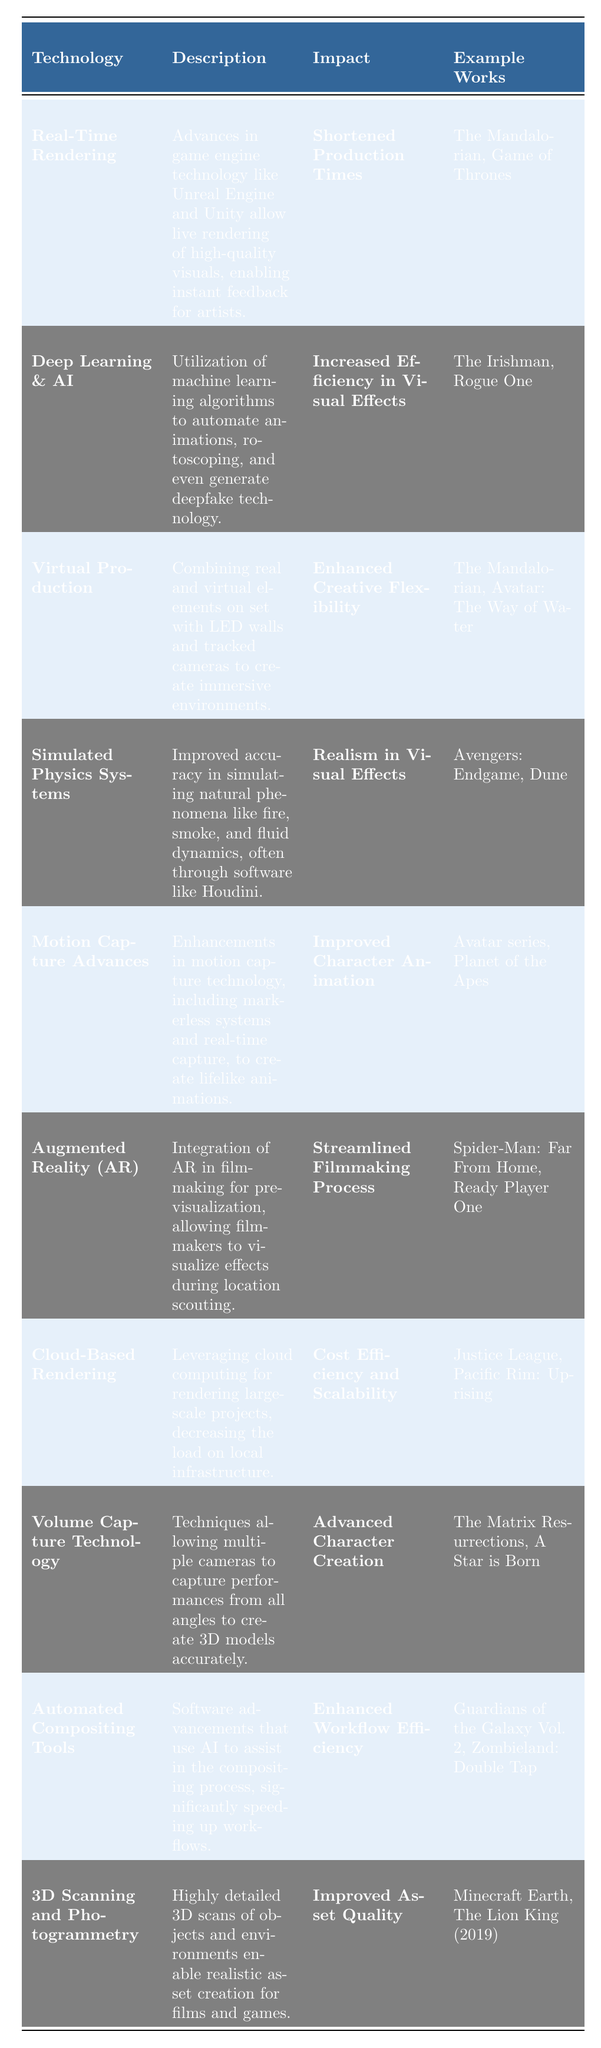What is the technology associated with the "Increased Efficiency in Visual Effects"? By looking in the "Impact" column and finding "Increased Efficiency in Visual Effects", the associated technology in the same row is "Deep Learning & AI".
Answer: Deep Learning & AI Which technology has the impact of "Realism in Visual Effects"? In the "Impact" column, the entry "Realism in Visual Effects" corresponds to "Simulated Physics Systems" in the same row.
Answer: Simulated Physics Systems How many visual effects technologies are listed in the table? The table has a total of 10 entries, as each row corresponds to a specific technology.
Answer: 10 What are the example works associated with "Augmented Reality (AR)"? The "Example Works" column contains "Spider-Man: Far From Home, Ready Player One" for "Augmented Reality (AR)".
Answer: Spider-Man: Far From Home, Ready Player One Which technology improves character animation? Looking at the "Impact" column, "Improved Character Animation" points to "Motion Capture Advances".
Answer: Motion Capture Advances Is "Volume Capture Technology" associated with the impact of "Cost Efficiency and Scalability"? By checking the related impact for "Volume Capture Technology," we find that it has the impact of "Advanced Character Creation", not "Cost Efficiency and Scalability".
Answer: No What technologies have been used in "The Mandalorian"? The technologies listed with "The Mandalorian" as an example are "Real-Time Rendering" and "Virtual Production".
Answer: Real-Time Rendering, Virtual Production What is the combined output of the example works for technologies that have "Enhanced Workflow Efficiency"? The associated example works for "Enhanced Workflow Efficiency" is "Guardians of the Galaxy Vol. 2, Zombieland: Double Tap".
Answer: Guardians of the Galaxy Vol. 2, Zombieland: Double Tap Which technology has the least detailed description? The descriptions are relatively elaborate; however, comparing their lengths, "Cloud-Based Rendering" has a more straightforward explanation without technical details.
Answer: Cloud-Based Rendering What technology has been utilized in both "The Mandalorian" and "Avatar: The Way of Water"? "Virtual Production" is the technology referenced in both example works.
Answer: Virtual Production 